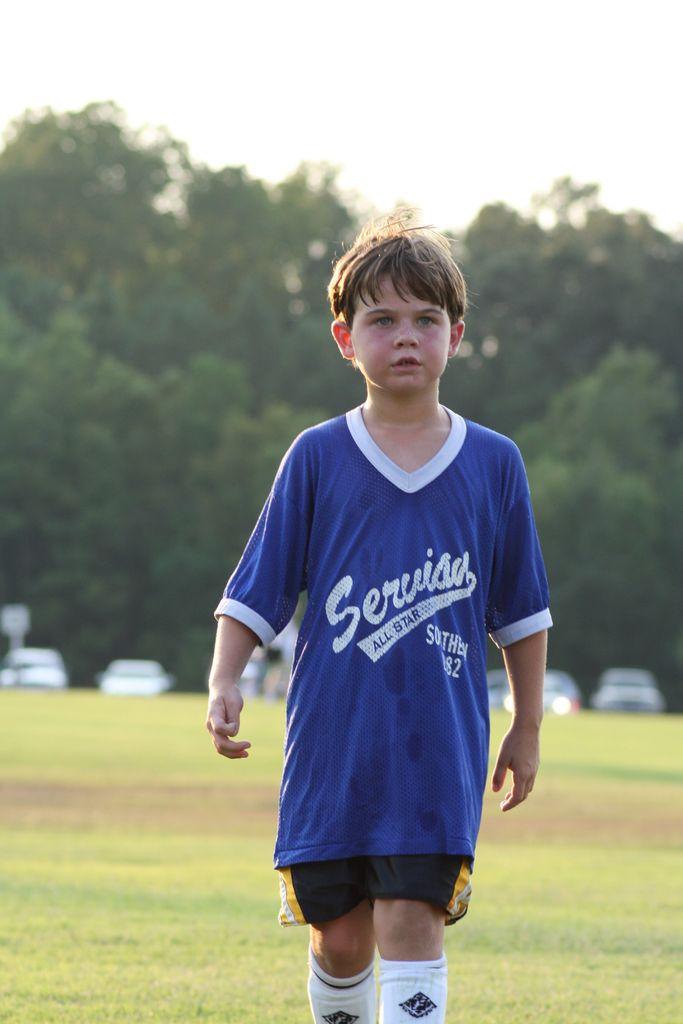What does his jersey say?
Keep it short and to the point. Serviso. 